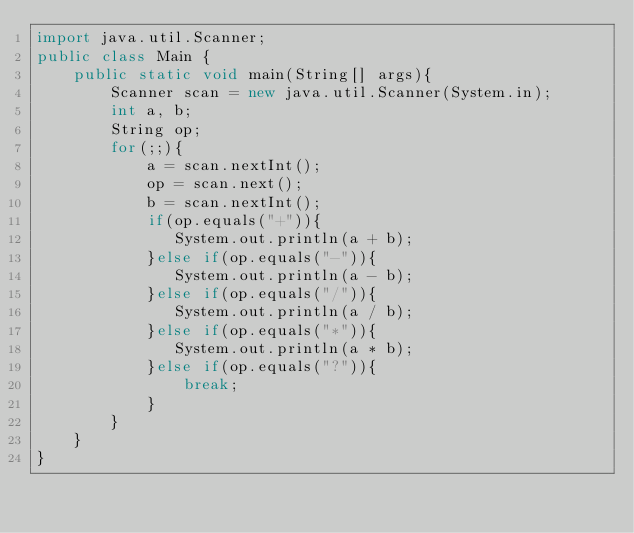Convert code to text. <code><loc_0><loc_0><loc_500><loc_500><_Java_>import java.util.Scanner;
public class Main {
    public static void main(String[] args){
        Scanner scan = new java.util.Scanner(System.in);
        int a, b;
        String op;
        for(;;){
            a = scan.nextInt();
            op = scan.next();
            b = scan.nextInt();
            if(op.equals("+")){
               System.out.println(a + b);
            }else if(op.equals("-")){
               System.out.println(a - b);
            }else if(op.equals("/")){
               System.out.println(a / b);
            }else if(op.equals("*")){
               System.out.println(a * b);
            }else if(op.equals("?")){
                break;
            }
        }
    }
}</code> 